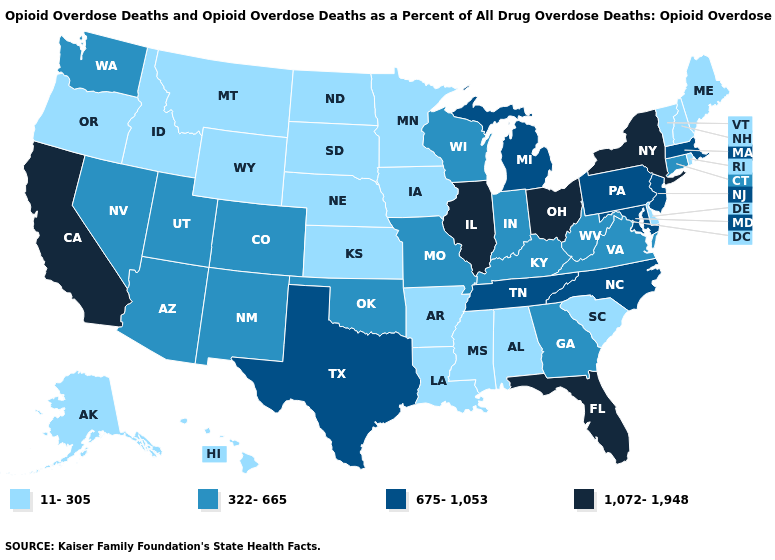Among the states that border Wisconsin , does Illinois have the highest value?
Quick response, please. Yes. Name the states that have a value in the range 322-665?
Keep it brief. Arizona, Colorado, Connecticut, Georgia, Indiana, Kentucky, Missouri, Nevada, New Mexico, Oklahoma, Utah, Virginia, Washington, West Virginia, Wisconsin. Name the states that have a value in the range 11-305?
Answer briefly. Alabama, Alaska, Arkansas, Delaware, Hawaii, Idaho, Iowa, Kansas, Louisiana, Maine, Minnesota, Mississippi, Montana, Nebraska, New Hampshire, North Dakota, Oregon, Rhode Island, South Carolina, South Dakota, Vermont, Wyoming. Does California have the highest value in the West?
Write a very short answer. Yes. What is the lowest value in states that border Rhode Island?
Answer briefly. 322-665. Does Wisconsin have the lowest value in the MidWest?
Answer briefly. No. Which states hav the highest value in the Northeast?
Give a very brief answer. New York. Does New York have the highest value in the Northeast?
Answer briefly. Yes. What is the value of Florida?
Short answer required. 1,072-1,948. Does Delaware have the lowest value in the USA?
Give a very brief answer. Yes. What is the value of Florida?
Answer briefly. 1,072-1,948. Which states have the lowest value in the USA?
Quick response, please. Alabama, Alaska, Arkansas, Delaware, Hawaii, Idaho, Iowa, Kansas, Louisiana, Maine, Minnesota, Mississippi, Montana, Nebraska, New Hampshire, North Dakota, Oregon, Rhode Island, South Carolina, South Dakota, Vermont, Wyoming. Does Louisiana have the highest value in the USA?
Quick response, please. No. Which states have the highest value in the USA?
Concise answer only. California, Florida, Illinois, New York, Ohio. What is the lowest value in states that border Louisiana?
Short answer required. 11-305. 